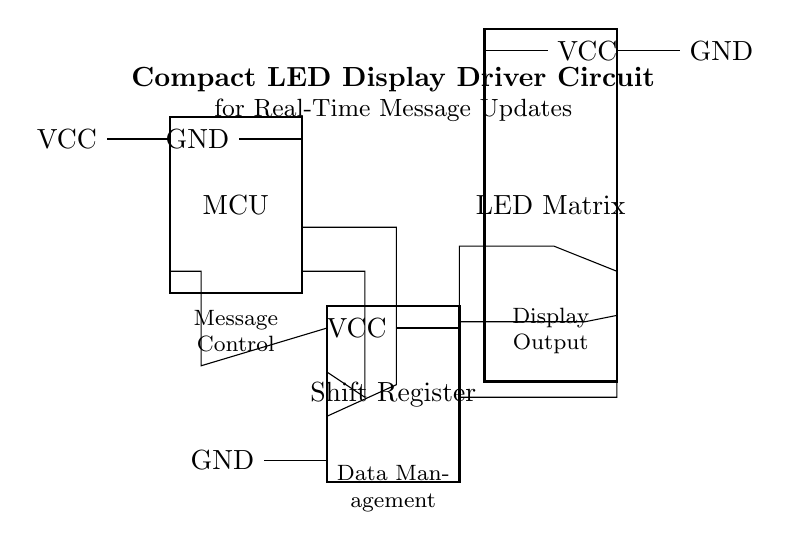What component controls the message updates? The microcontroller (MCU) is responsible for controlling message updates as it interfaces with the shift register to send data.
Answer: MCU How many pins does the shift register have? The shift register shown has 8 pins, as indicated in the diagram.
Answer: 8 What is the power voltage supply for the LED matrix? The LED matrix is powered by a voltage of 5V, as noted next to its power input connection.
Answer: 5V Which component is responsible for data management? The shift register is tasked with data management, transferring data to the LED matrix based on signals from the microcontroller.
Answer: Shift Register How many output pins from the shift register connect to the LED matrix? Three output pins from the shift register connect to the LED matrix, facilitating data transmission for display updates.
Answer: 3 What type of circuit is this? This is a display driver circuit, specifically designed for real-time message updates to an LED matrix.
Answer: Display Driver Circuit 